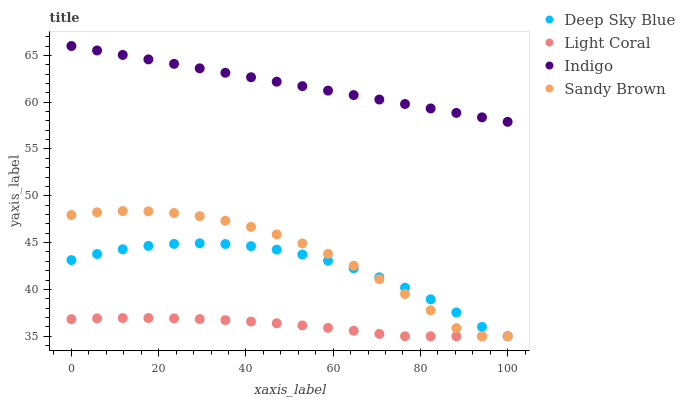Does Light Coral have the minimum area under the curve?
Answer yes or no. Yes. Does Indigo have the maximum area under the curve?
Answer yes or no. Yes. Does Sandy Brown have the minimum area under the curve?
Answer yes or no. No. Does Sandy Brown have the maximum area under the curve?
Answer yes or no. No. Is Indigo the smoothest?
Answer yes or no. Yes. Is Sandy Brown the roughest?
Answer yes or no. Yes. Is Sandy Brown the smoothest?
Answer yes or no. No. Is Indigo the roughest?
Answer yes or no. No. Does Light Coral have the lowest value?
Answer yes or no. Yes. Does Indigo have the lowest value?
Answer yes or no. No. Does Indigo have the highest value?
Answer yes or no. Yes. Does Sandy Brown have the highest value?
Answer yes or no. No. Is Light Coral less than Indigo?
Answer yes or no. Yes. Is Indigo greater than Deep Sky Blue?
Answer yes or no. Yes. Does Light Coral intersect Deep Sky Blue?
Answer yes or no. Yes. Is Light Coral less than Deep Sky Blue?
Answer yes or no. No. Is Light Coral greater than Deep Sky Blue?
Answer yes or no. No. Does Light Coral intersect Indigo?
Answer yes or no. No. 